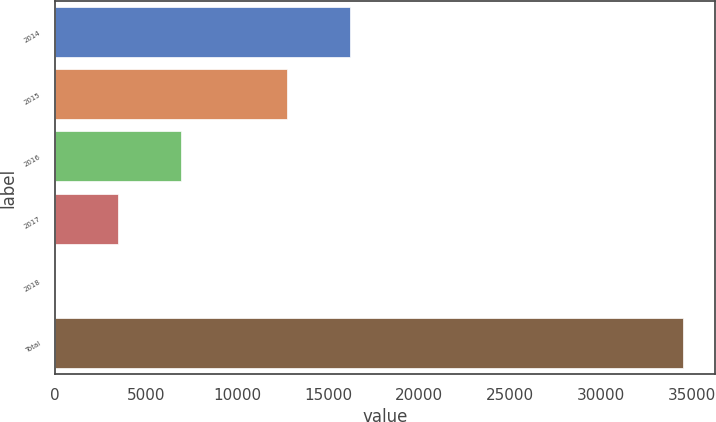<chart> <loc_0><loc_0><loc_500><loc_500><bar_chart><fcel>2014<fcel>2015<fcel>2016<fcel>2017<fcel>2018<fcel>Total<nl><fcel>16201<fcel>12752<fcel>6923<fcel>3474<fcel>25<fcel>34515<nl></chart> 